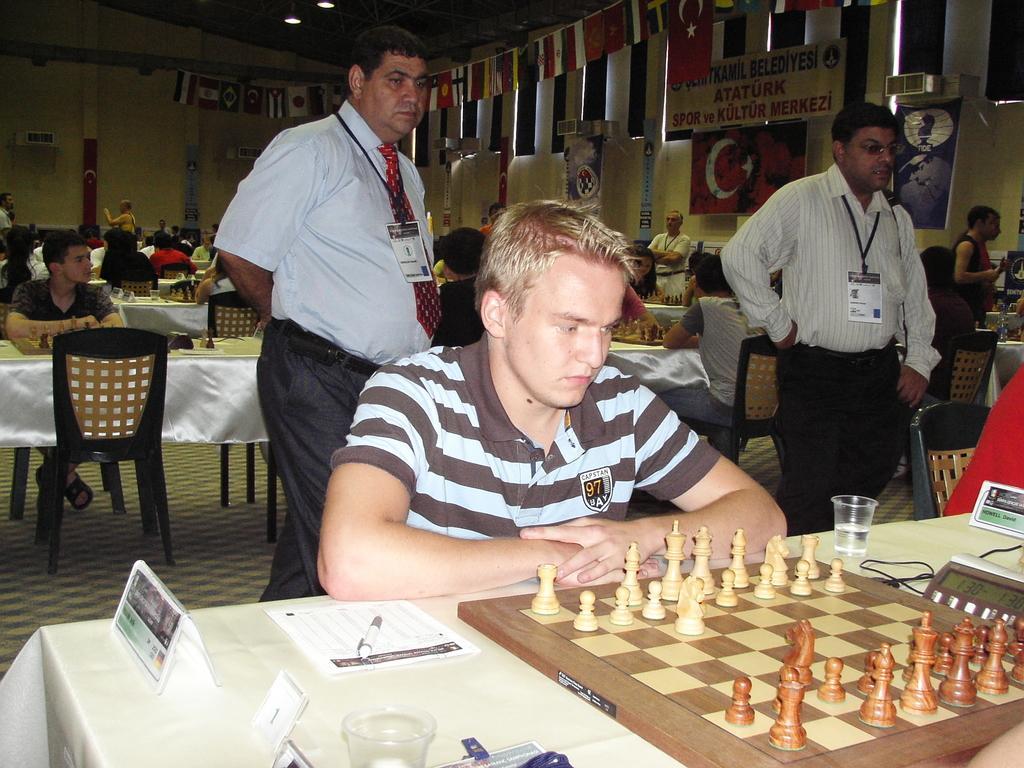How would you summarize this image in a sentence or two? In this picture we can see man sitting on chair and in front of him we can see chess board, glass, timer, paper, pen on table and at back of him we can see two persons standing and in background we can see some more persons and tables, wall, banners. 